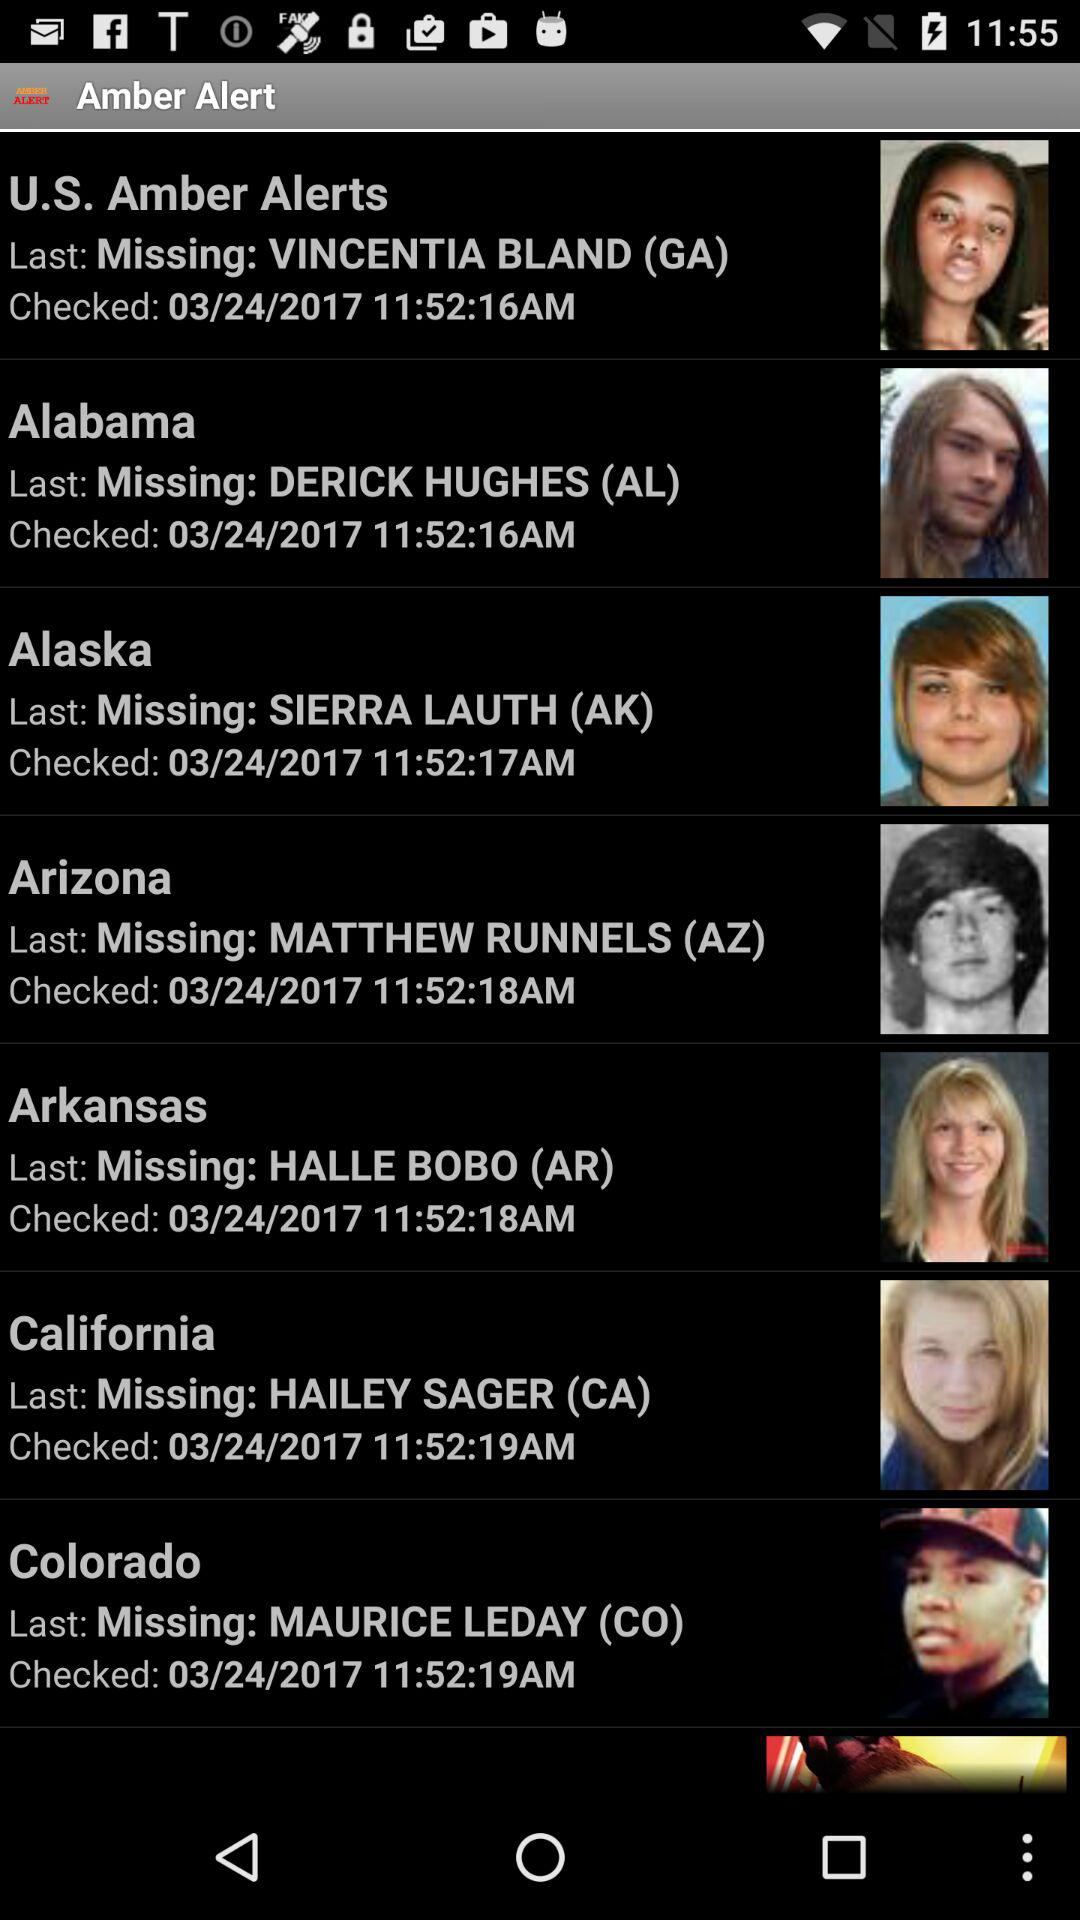What is the checked date of the amber alert for Hailey Sager? The checked date of the amber alert for Hailey Sager is March 24, 2017. 